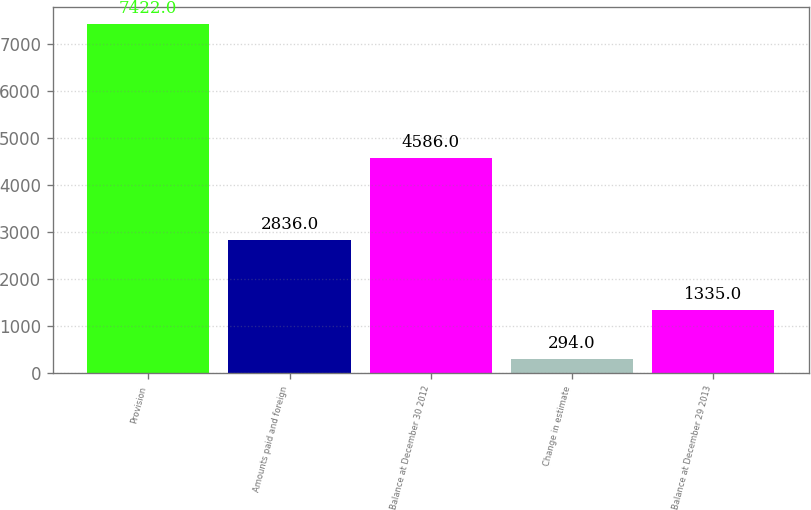<chart> <loc_0><loc_0><loc_500><loc_500><bar_chart><fcel>Provision<fcel>Amounts paid and foreign<fcel>Balance at December 30 2012<fcel>Change in estimate<fcel>Balance at December 29 2013<nl><fcel>7422<fcel>2836<fcel>4586<fcel>294<fcel>1335<nl></chart> 